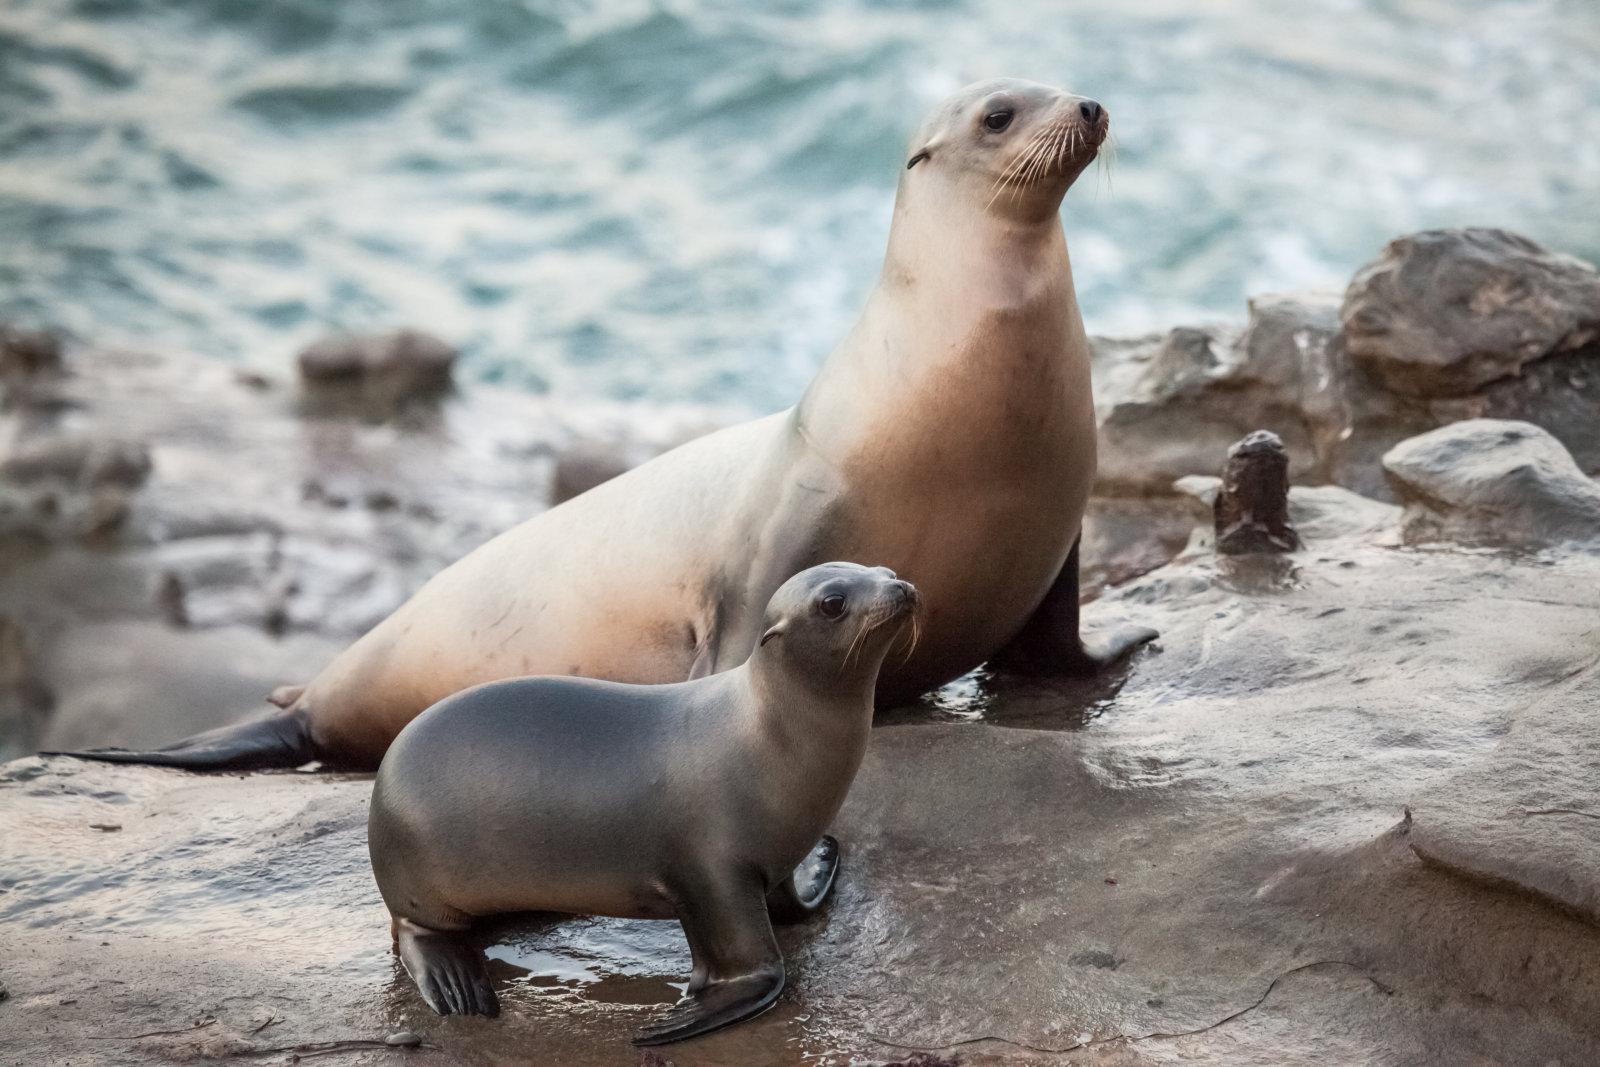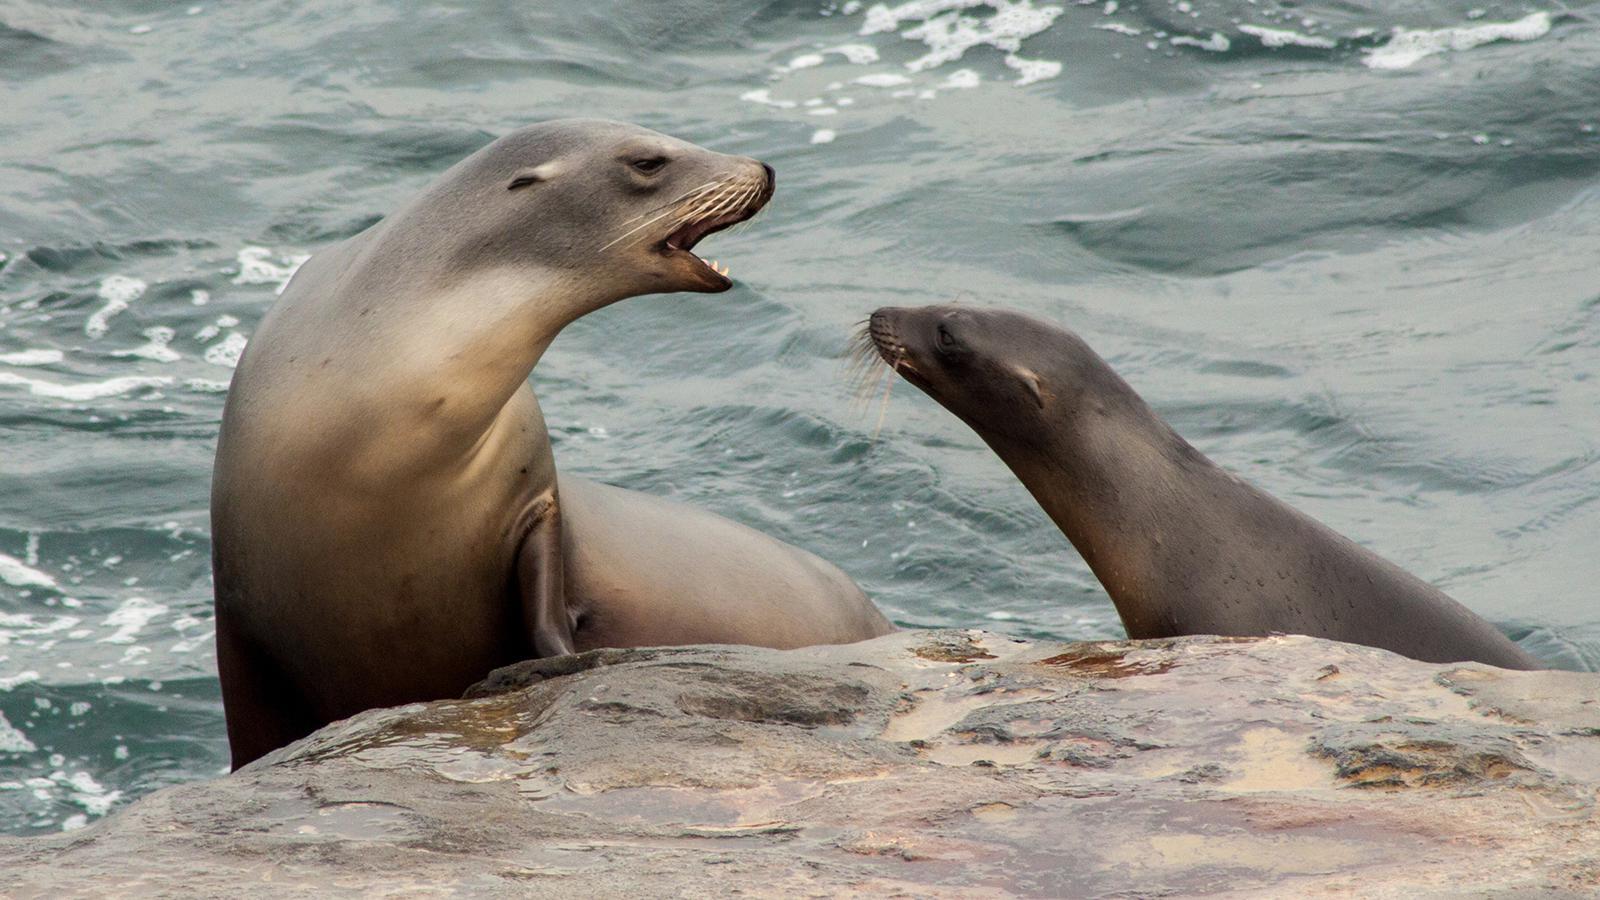The first image is the image on the left, the second image is the image on the right. Considering the images on both sides, is "Two seals appear to be communicating face to face." valid? Answer yes or no. Yes. The first image is the image on the left, the second image is the image on the right. Assess this claim about the two images: "The lefthand image contains two different-sized seals, both with their heads upright.". Correct or not? Answer yes or no. Yes. 